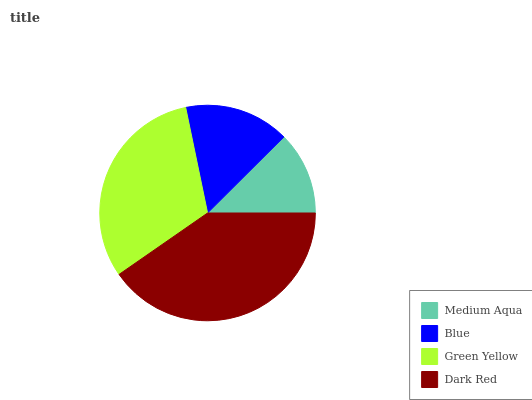Is Medium Aqua the minimum?
Answer yes or no. Yes. Is Dark Red the maximum?
Answer yes or no. Yes. Is Blue the minimum?
Answer yes or no. No. Is Blue the maximum?
Answer yes or no. No. Is Blue greater than Medium Aqua?
Answer yes or no. Yes. Is Medium Aqua less than Blue?
Answer yes or no. Yes. Is Medium Aqua greater than Blue?
Answer yes or no. No. Is Blue less than Medium Aqua?
Answer yes or no. No. Is Green Yellow the high median?
Answer yes or no. Yes. Is Blue the low median?
Answer yes or no. Yes. Is Blue the high median?
Answer yes or no. No. Is Green Yellow the low median?
Answer yes or no. No. 